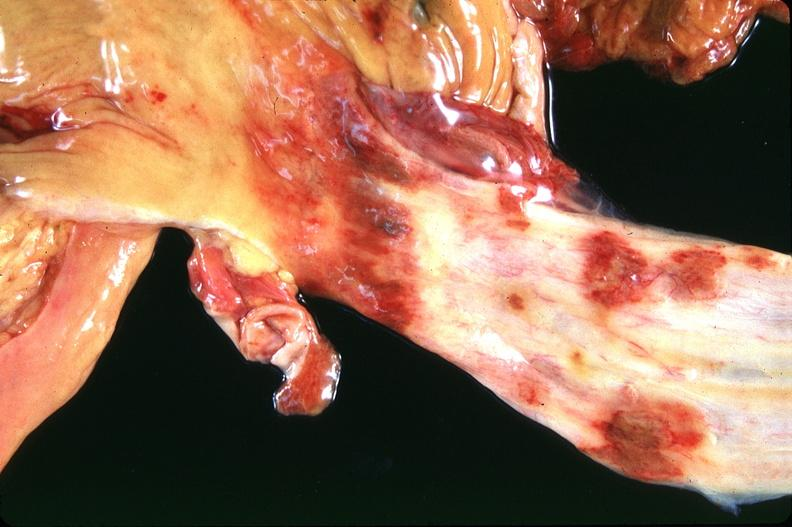does cardiovascular show stomach and esophagus, ulcers?
Answer the question using a single word or phrase. No 